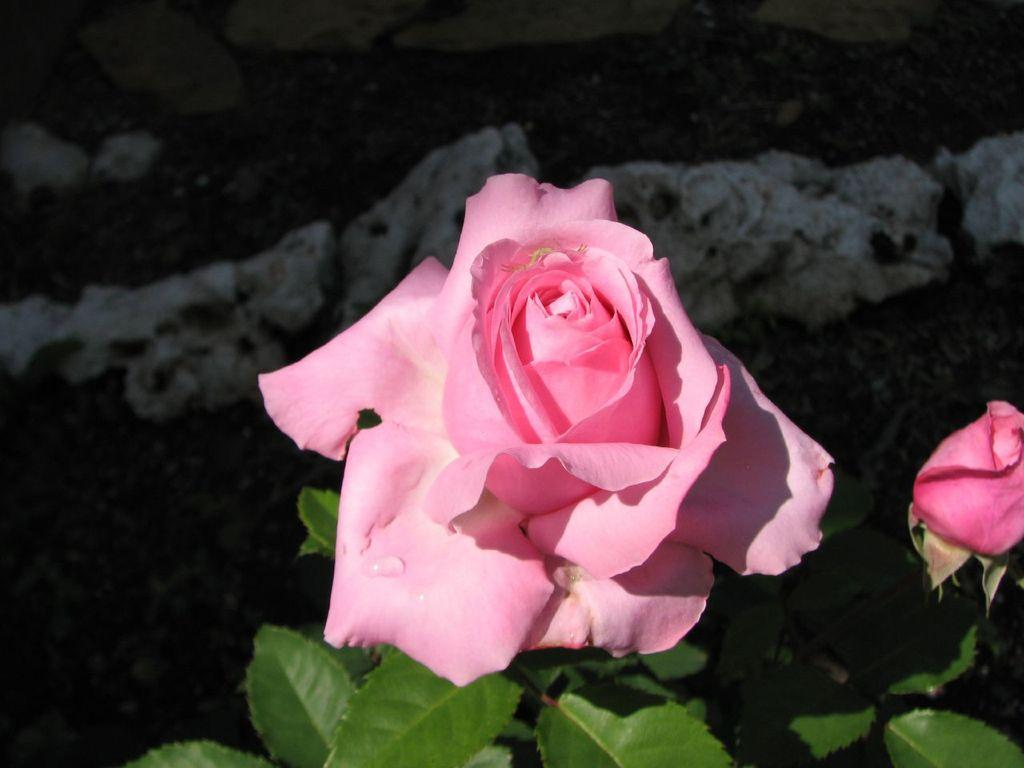What type of flower can be seen in the image? There is a rose flower in the image. Can you describe the stage of growth of the flower in the image? There is a flower bud in the image, indicating that it is not yet fully bloomed. What type of foliage is present at the bottom of the image? There are green leaves at the bottom of the image. What can be seen in the background of the image? There is a wall in the background of the image. What is the condition of the flower in the image? Water drops are visible in the image, suggesting that the flower may have been recently watered or exposed to moisture. What type of birds can be seen flying around the rose flower in the image? There are no birds visible in the image; it only features a rose flower, a flower bud, green leaves, a wall in the background, and water drops. 